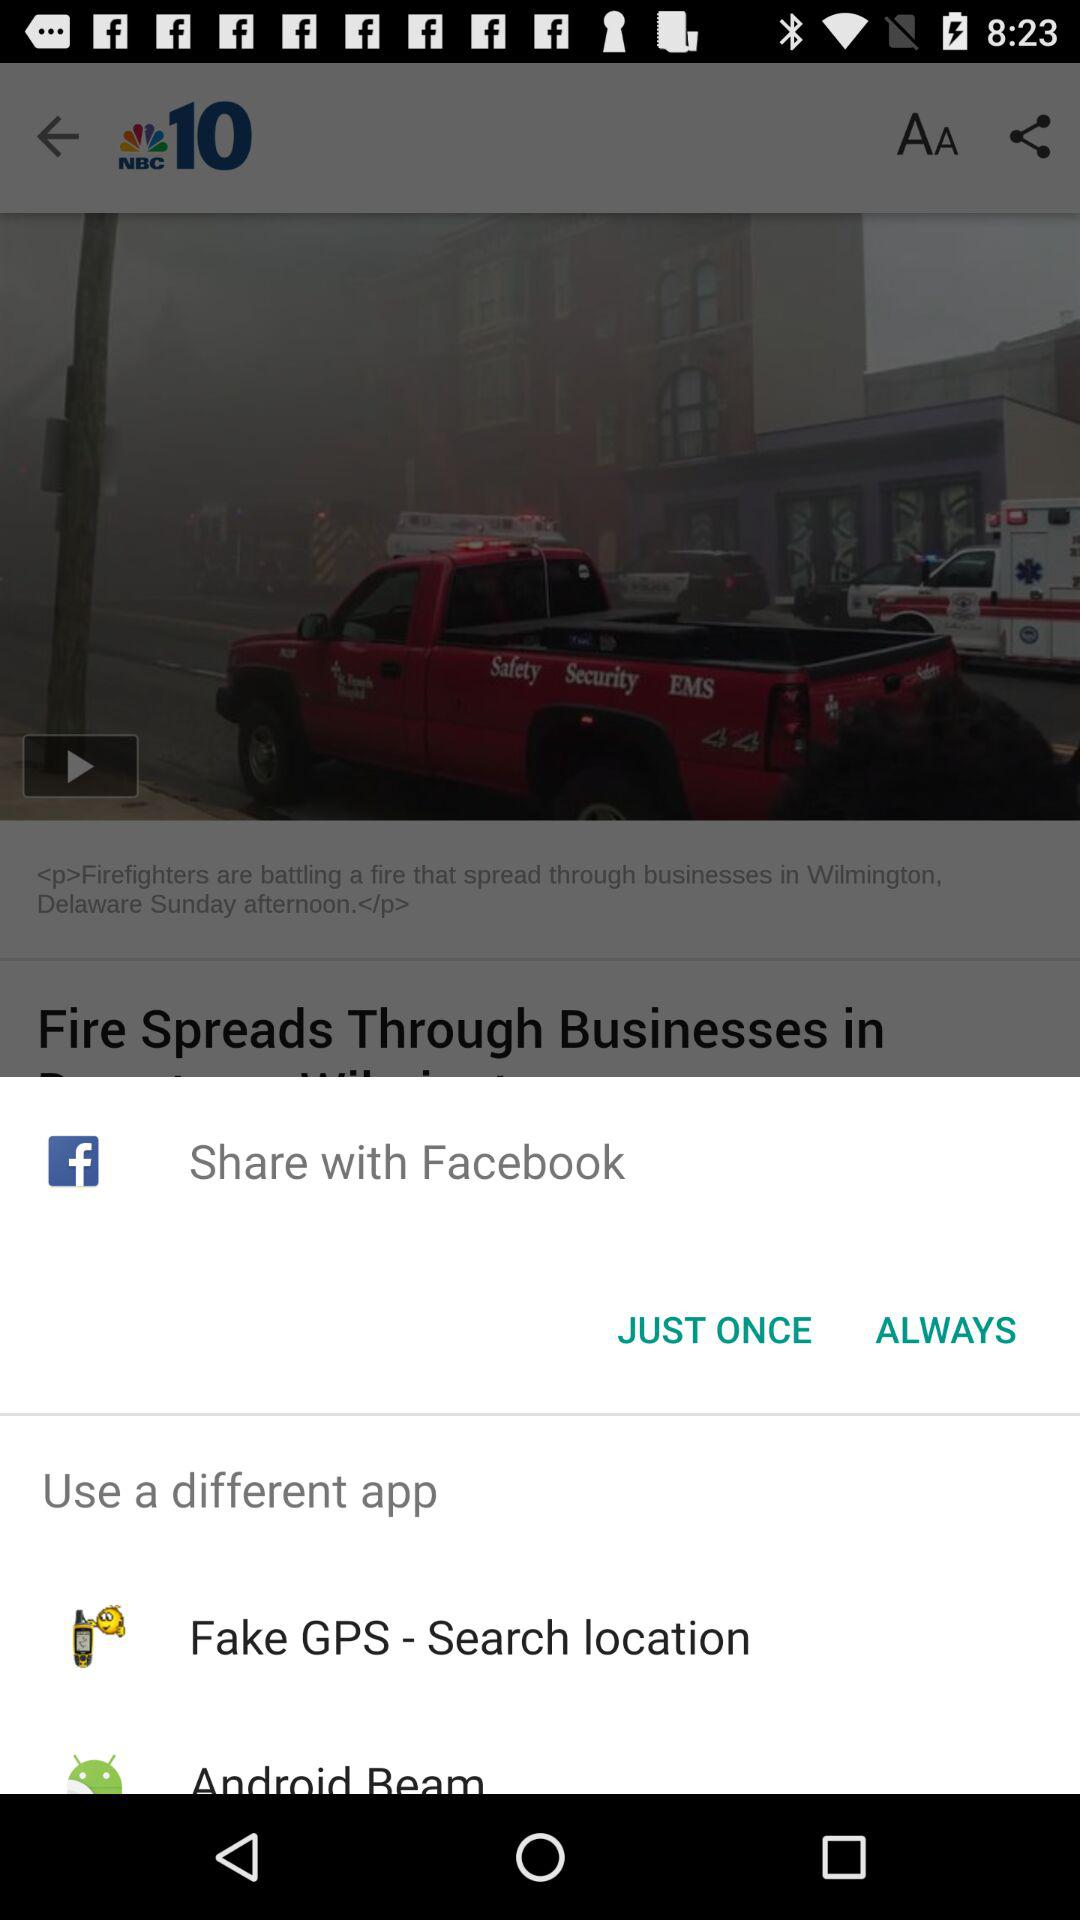By which app can we share the content? You can share the content with "Facebook", "Fake GPS - Search location" and "Android Beam". 